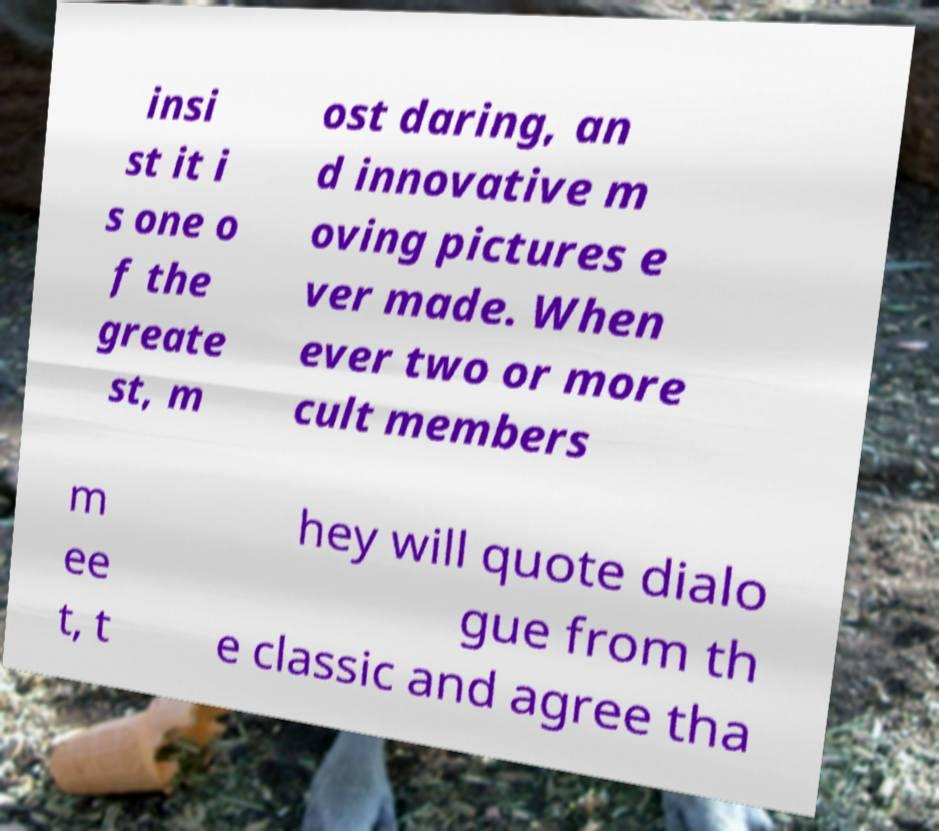Please read and relay the text visible in this image. What does it say? insi st it i s one o f the greate st, m ost daring, an d innovative m oving pictures e ver made. When ever two or more cult members m ee t, t hey will quote dialo gue from th e classic and agree tha 